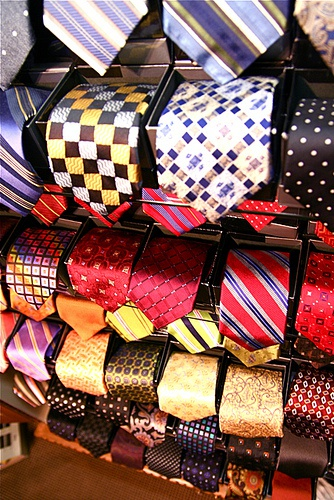Describe the objects in this image and their specific colors. I can see tie in darkgray, black, maroon, white, and khaki tones, tie in darkgray, white, lightpink, and navy tones, tie in darkgray, white, black, khaki, and gray tones, tie in darkgray, red, lightgray, and maroon tones, and tie in darkgray, maroon, salmon, black, and red tones in this image. 